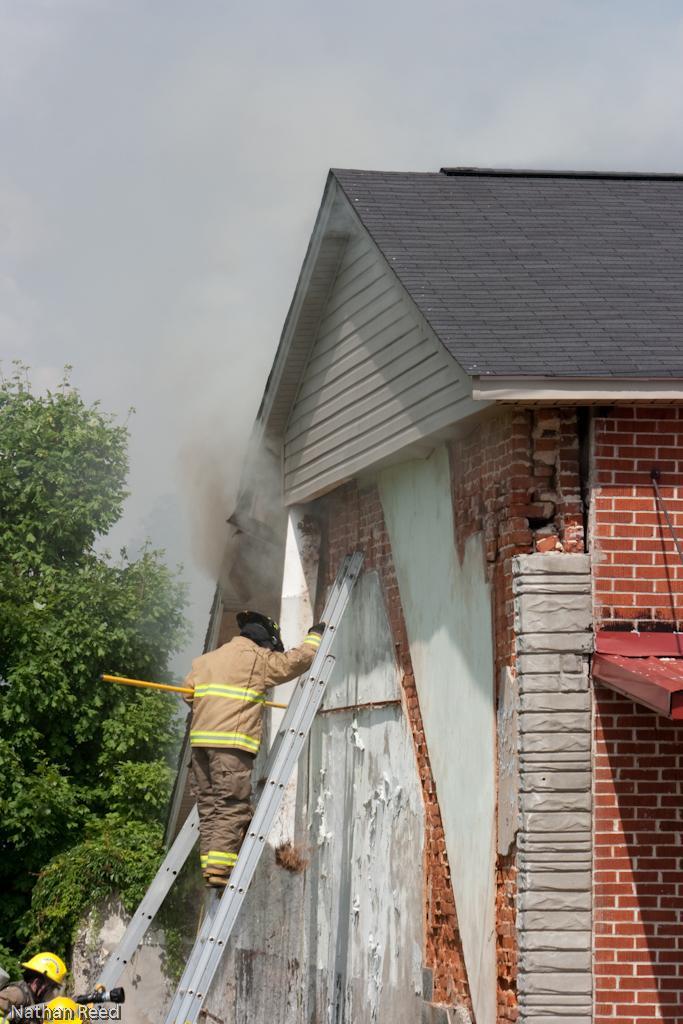Could you give a brief overview of what you see in this image? In this image we can see a person is standing on the ladder. Here we can see a house, plants, leaves, and smoke. In the background there is sky. At the bottom of the image we can see a person and an object. 